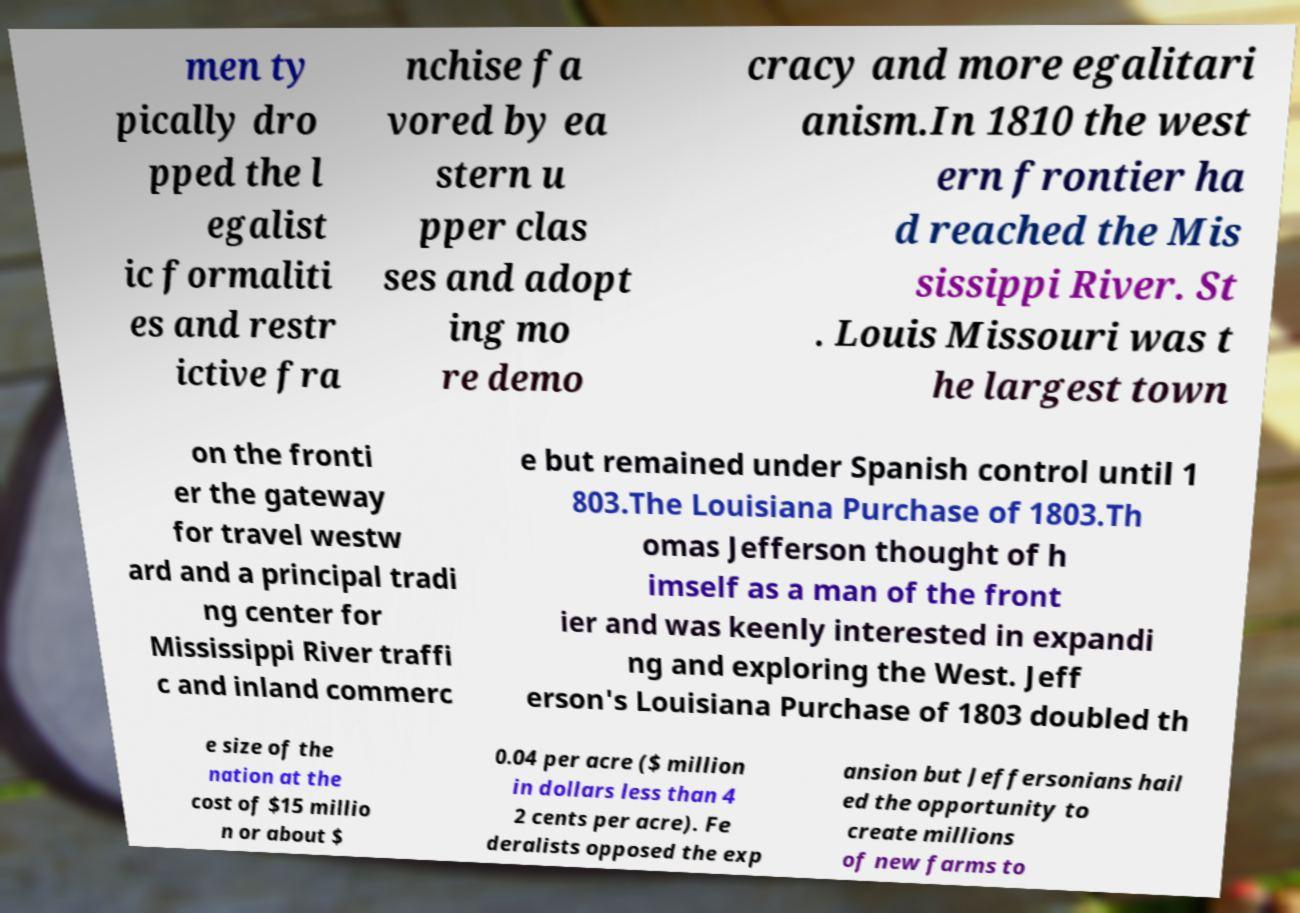For documentation purposes, I need the text within this image transcribed. Could you provide that? men ty pically dro pped the l egalist ic formaliti es and restr ictive fra nchise fa vored by ea stern u pper clas ses and adopt ing mo re demo cracy and more egalitari anism.In 1810 the west ern frontier ha d reached the Mis sissippi River. St . Louis Missouri was t he largest town on the fronti er the gateway for travel westw ard and a principal tradi ng center for Mississippi River traffi c and inland commerc e but remained under Spanish control until 1 803.The Louisiana Purchase of 1803.Th omas Jefferson thought of h imself as a man of the front ier and was keenly interested in expandi ng and exploring the West. Jeff erson's Louisiana Purchase of 1803 doubled th e size of the nation at the cost of $15 millio n or about $ 0.04 per acre ($ million in dollars less than 4 2 cents per acre). Fe deralists opposed the exp ansion but Jeffersonians hail ed the opportunity to create millions of new farms to 